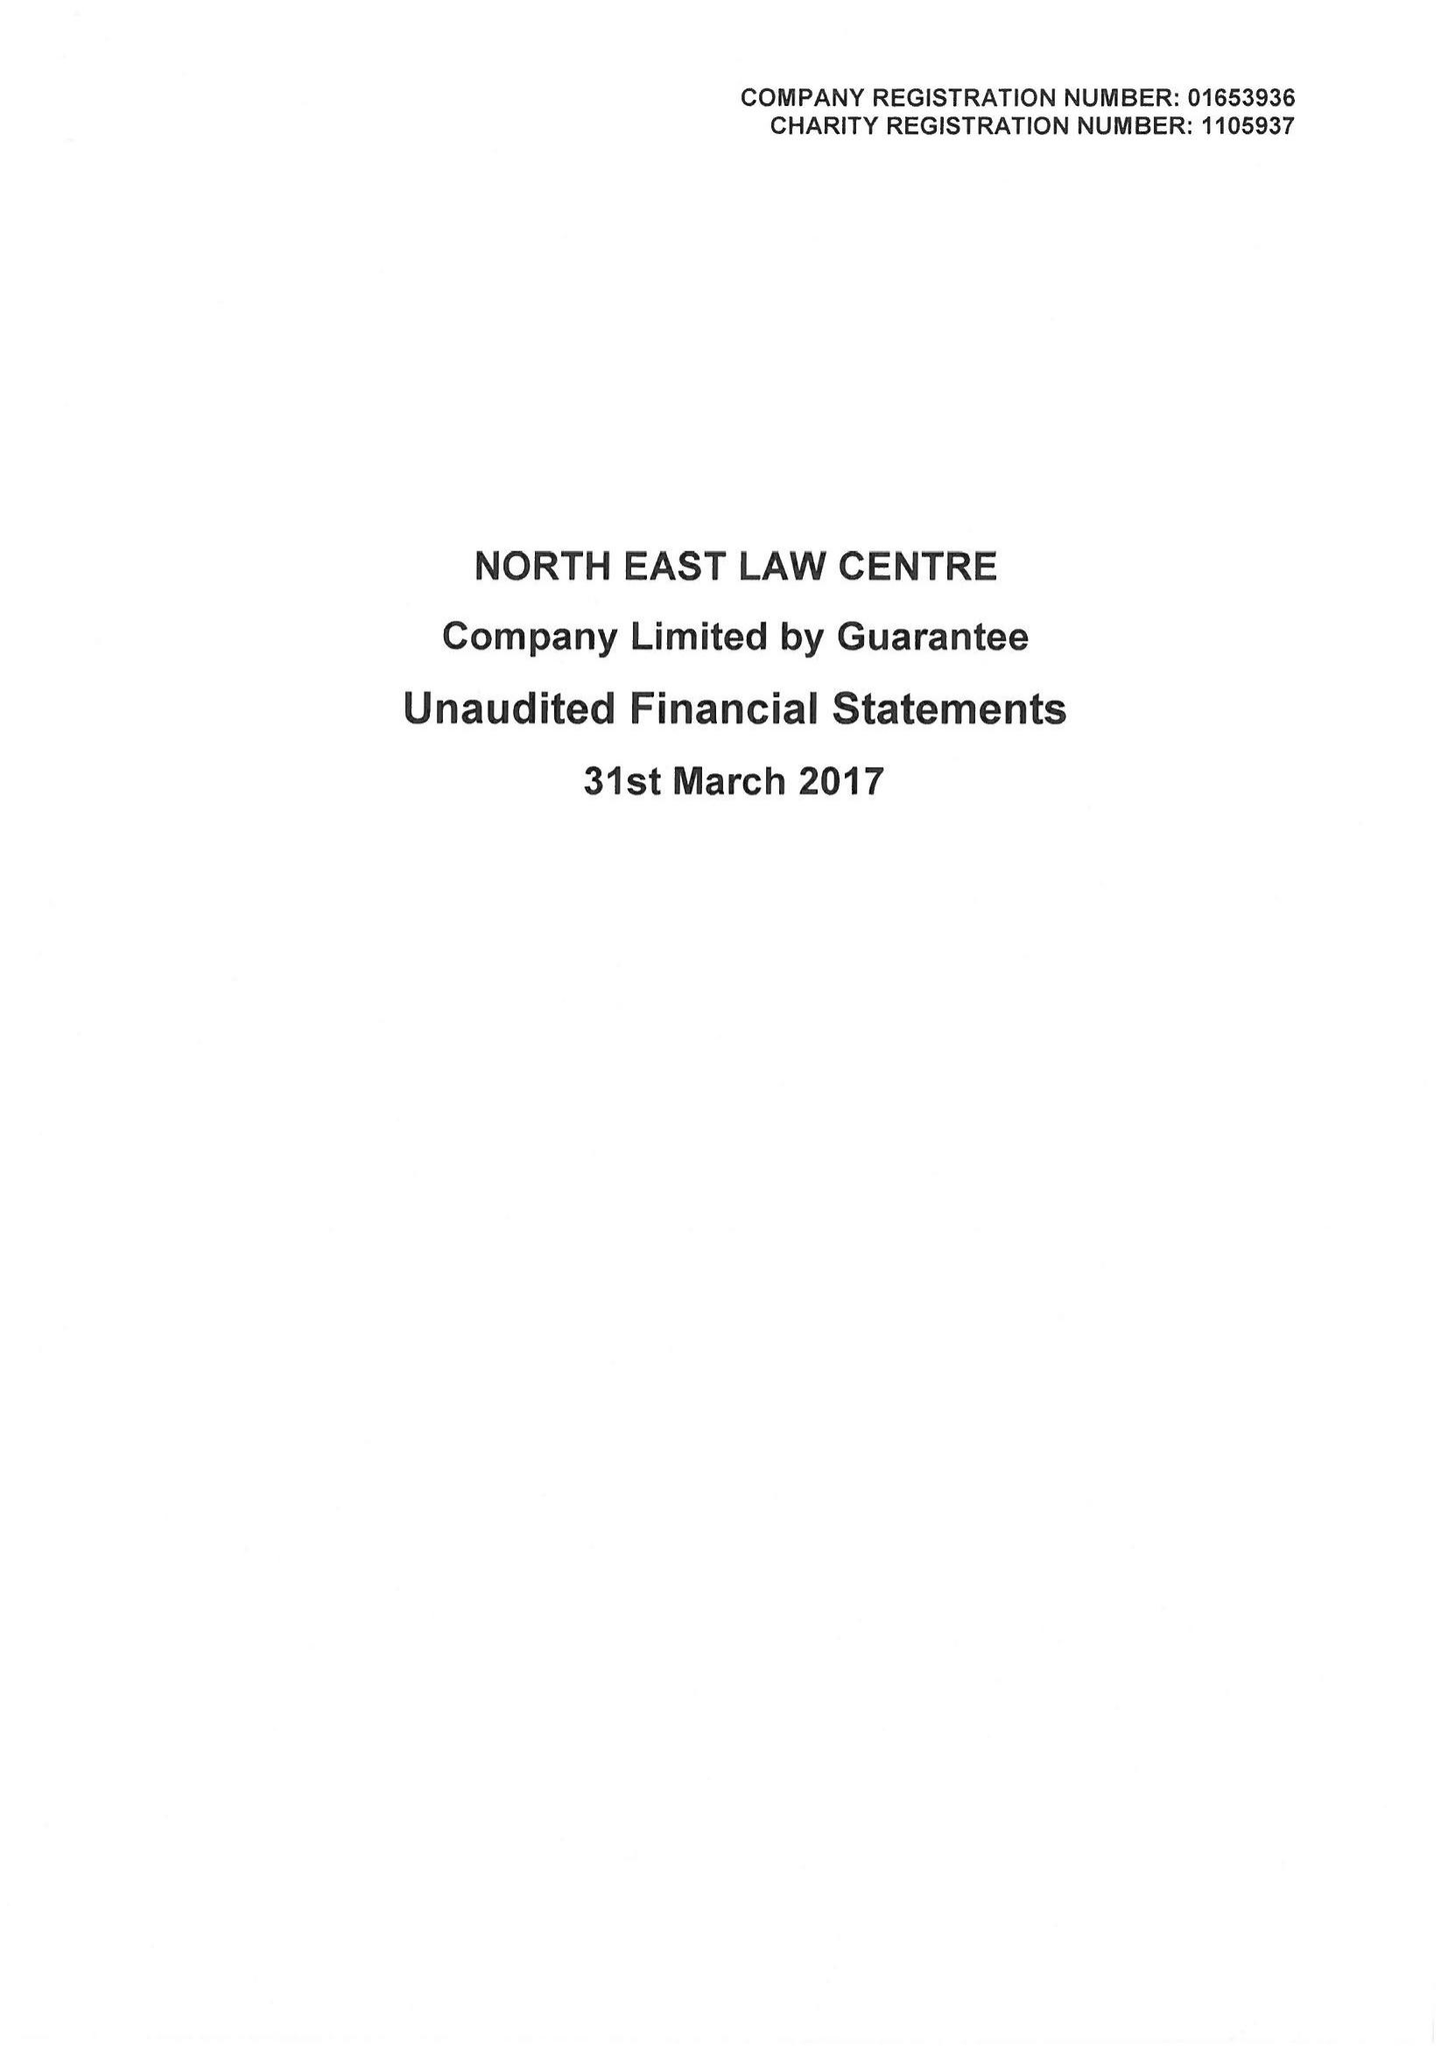What is the value for the report_date?
Answer the question using a single word or phrase. 2017-03-31 